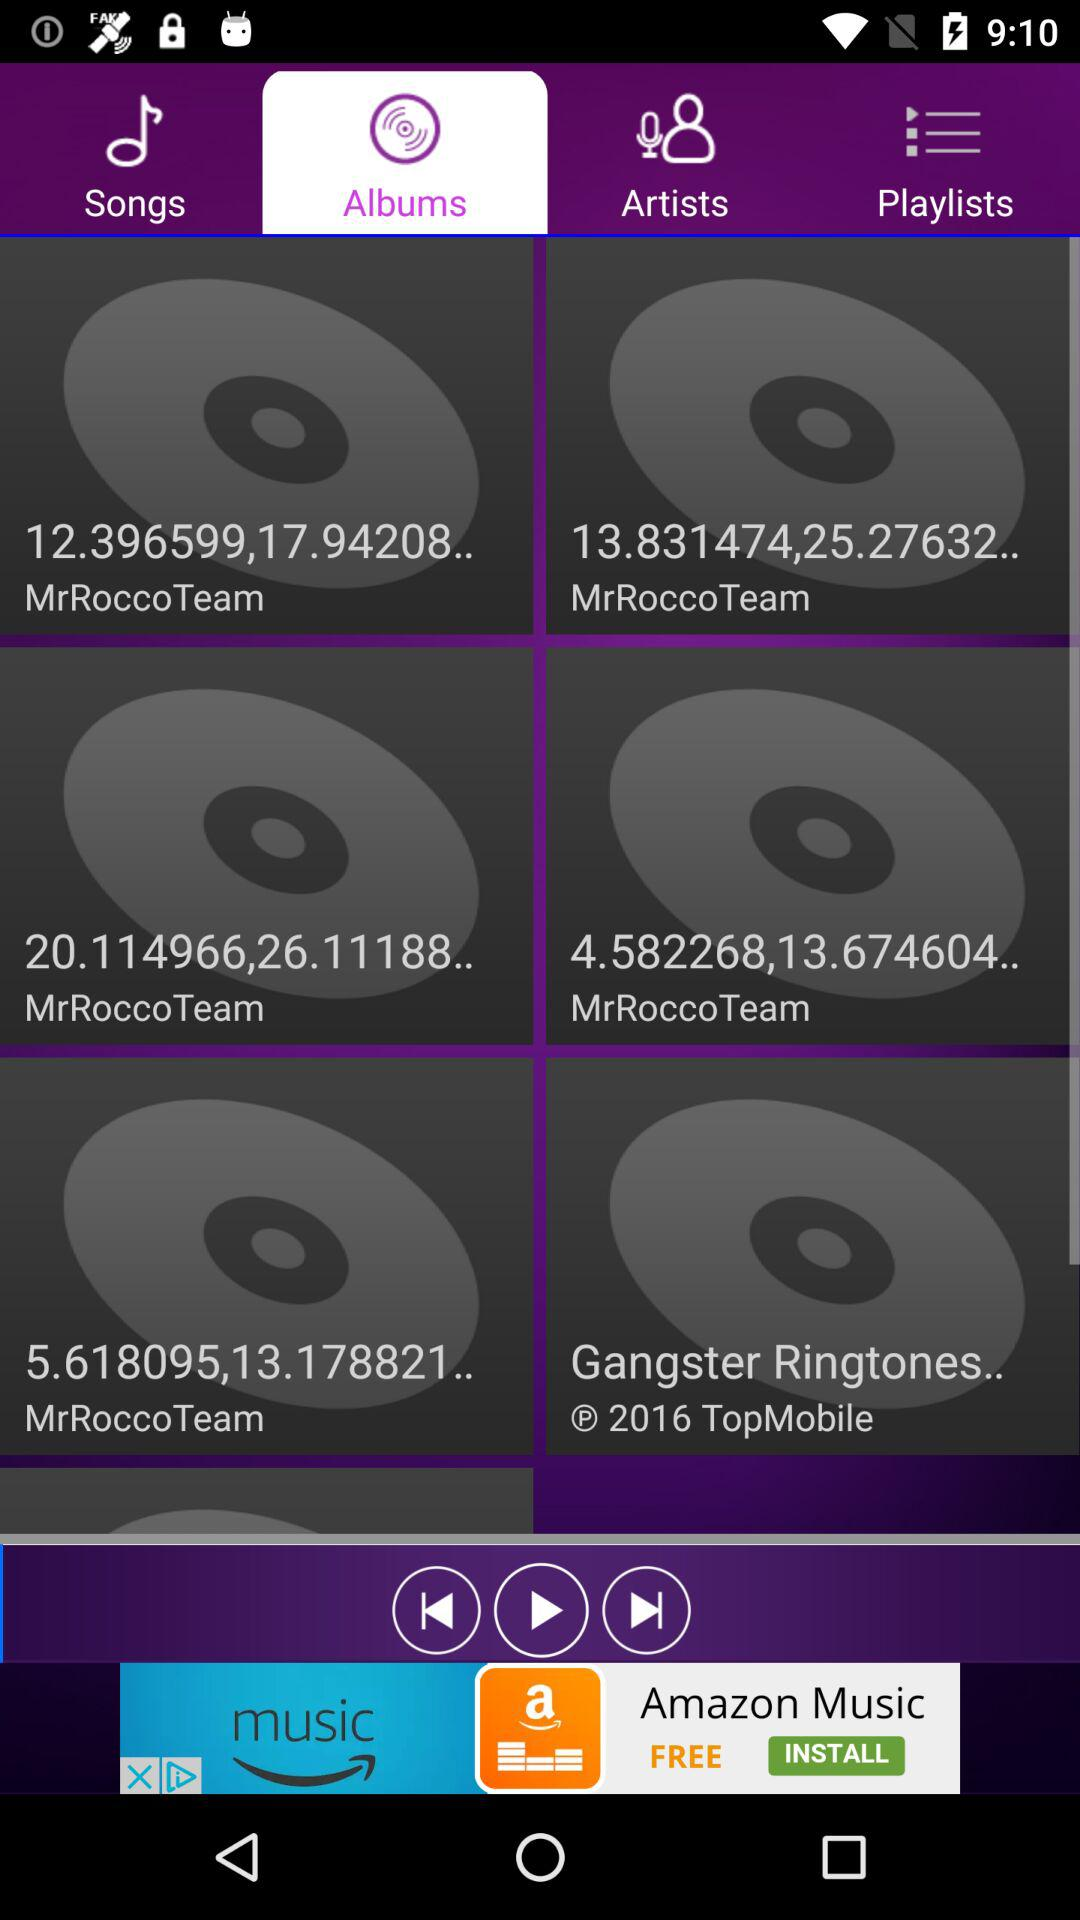Which tab is currently selected? The currently selected tab is "Albums". 